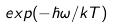Convert formula to latex. <formula><loc_0><loc_0><loc_500><loc_500>e x p ( - \hbar { \omega } / k T )</formula> 